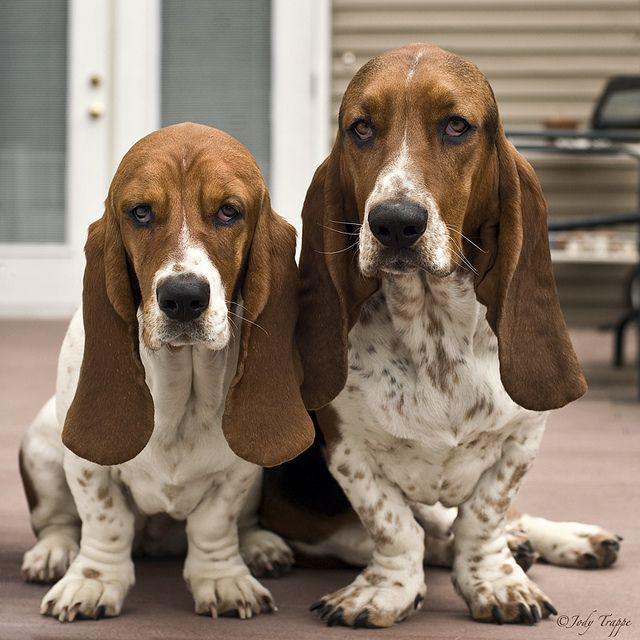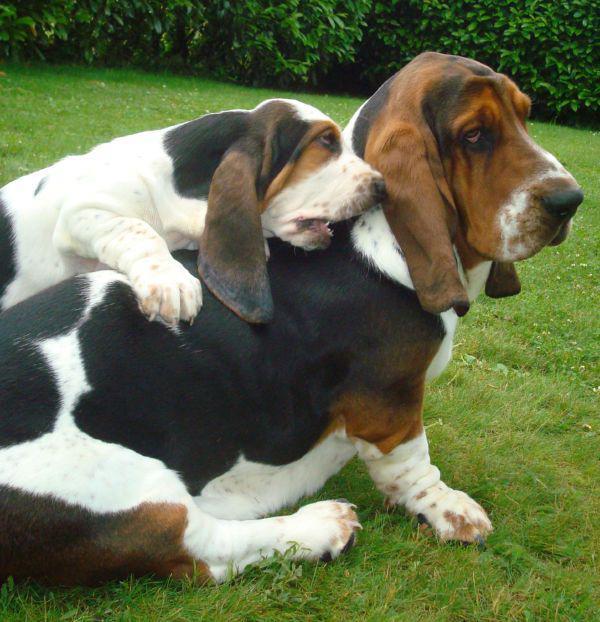The first image is the image on the left, the second image is the image on the right. Examine the images to the left and right. Is the description "One image shows a large basset hound on green grass, with at least one smaller hound touching it, and the other image features exactly two hounds side-by-side." accurate? Answer yes or no. Yes. The first image is the image on the left, the second image is the image on the right. For the images displayed, is the sentence "The dogs in the image on the right are outside in the grass." factually correct? Answer yes or no. Yes. 